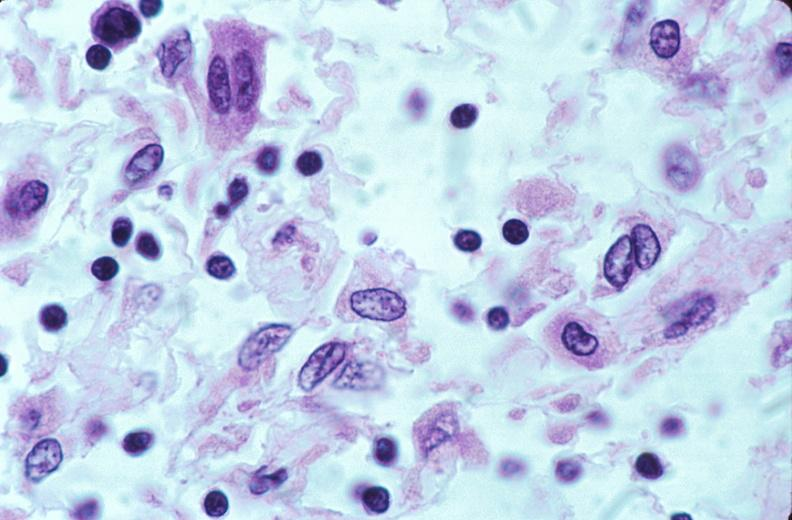what does this image show?
Answer the question using a single word or phrase. Lymph nodes 